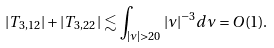Convert formula to latex. <formula><loc_0><loc_0><loc_500><loc_500>| T _ { 3 , 1 2 } | + | T _ { 3 , 2 2 } | \lesssim \int _ { | \nu | > 2 0 } | \nu | ^ { - 3 } d \nu = O ( 1 ) .</formula> 